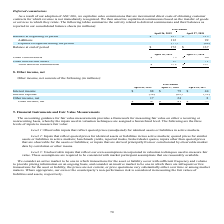According to Netapp's financial document, Why did the company capitalize sales commissions that are incremental direct costs of obtaining customer contracts for which revenue is not immediately recognized? a result of our adoption of ASC 606. The document states: "As a result of our adoption of ASC 606, we capitalize sales commissions that are incremental direct costs of obtaining customer contracts..." Also, What was the balance at beginning of period in 2019? According to the financial document, 137 (in millions). The relevant text states: "Total deferred commissions $ 172 $ 137..." Also, What does the table show? summarize the activity related to deferred commissions and their balances as reported in our consolidated balance sheets. The document states: "rvices to which they relate. The following tables summarize the activity related to deferred commissions and their balances as reported in our consoli..." Also, can you calculate: What was the change in Other current assets between 2018 and 2019? Based on the calculation: 75-66, the result is 9 (in millions). This is based on the information: "Other current assets $ 75 $ 66 Other current assets $ 75 $ 66..." The key data points involved are: 66, 75. Also, can you calculate: What was the change in Total deferred commissions between 2018 and 2019? Based on the calculation: 172-137, the result is 35 (in millions). This is based on the information: "Total deferred commissions $ 172 $ 137 Total deferred commissions $ 172 $ 137..." The key data points involved are: 137, 172. Also, can you calculate: What was the percentage change in  Total deferred commissions between 2018 and 2019? To answer this question, I need to perform calculations using the financial data. The calculation is: (172-137)/137, which equals 25.55 (percentage). This is based on the information: "Total deferred commissions $ 172 $ 137 Total deferred commissions $ 172 $ 137..." The key data points involved are: 137, 172. 